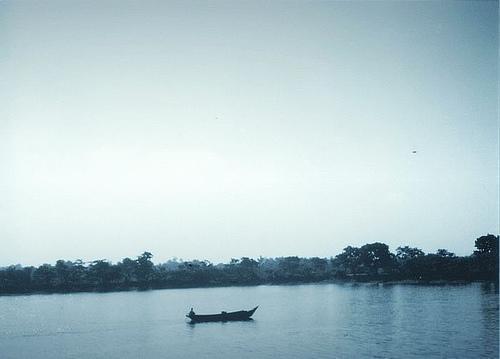How many umbrellas are on the boat?
Give a very brief answer. 0. 